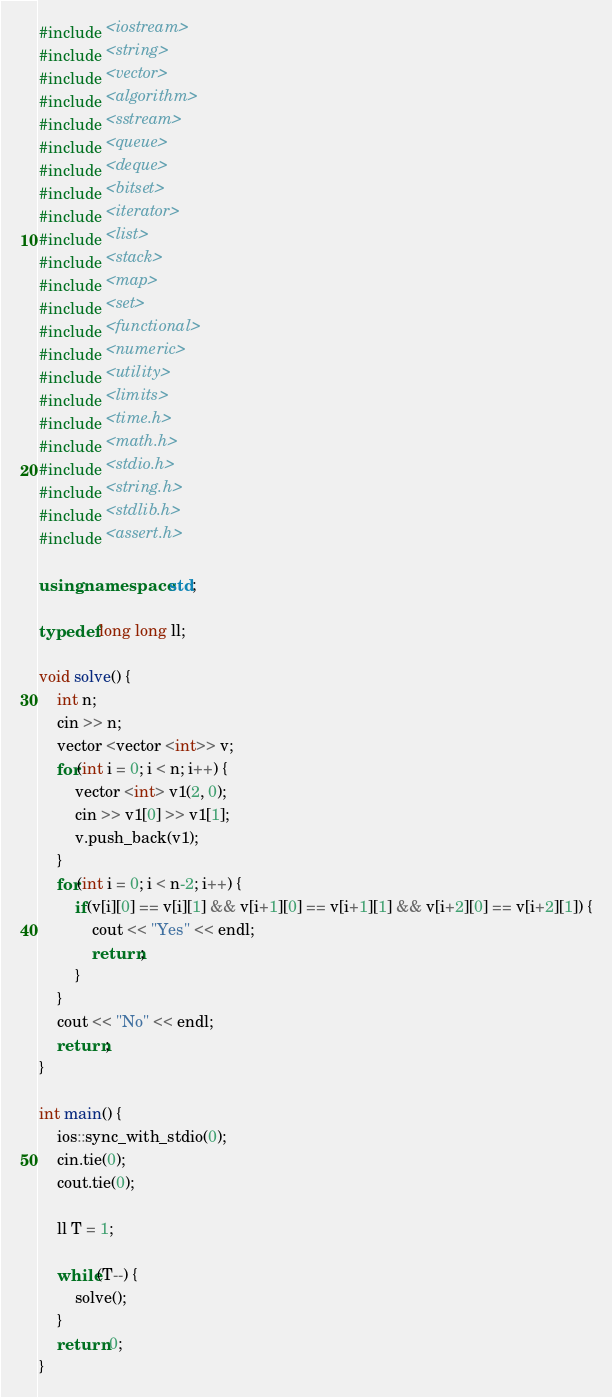Convert code to text. <code><loc_0><loc_0><loc_500><loc_500><_C++_>#include <iostream>
#include <string>
#include <vector>
#include <algorithm>
#include <sstream>
#include <queue>
#include <deque>
#include <bitset>
#include <iterator>
#include <list>
#include <stack>
#include <map>
#include <set>
#include <functional>
#include <numeric>
#include <utility>
#include <limits>
#include <time.h>
#include <math.h>
#include <stdio.h>
#include <string.h>
#include <stdlib.h>
#include <assert.h>

using namespace std;

typedef long long ll;

void solve() {
    int n; 
    cin >> n;
    vector <vector <int>> v;
    for(int i = 0; i < n; i++) {
        vector <int> v1(2, 0);
        cin >> v1[0] >> v1[1];
        v.push_back(v1);
    }
    for(int i = 0; i < n-2; i++) {
        if(v[i][0] == v[i][1] && v[i+1][0] == v[i+1][1] && v[i+2][0] == v[i+2][1]) {
            cout << "Yes" << endl;
            return;
        }
    }
    cout << "No" << endl;
    return;
}

int main() {
    ios::sync_with_stdio(0);
    cin.tie(0);
    cout.tie(0);

    ll T = 1;

    while(T--) {
        solve();
    }
    return 0;
}</code> 